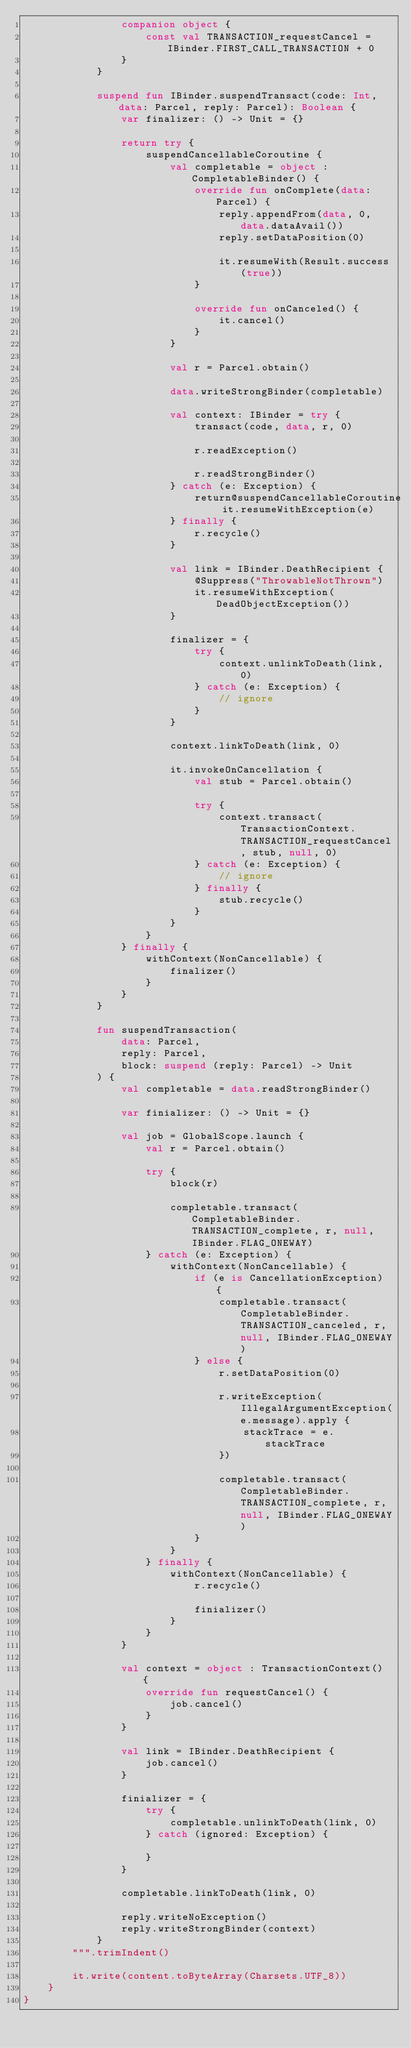<code> <loc_0><loc_0><loc_500><loc_500><_Kotlin_>                companion object {
                    const val TRANSACTION_requestCancel = IBinder.FIRST_CALL_TRANSACTION + 0
                }
            }

            suspend fun IBinder.suspendTransact(code: Int, data: Parcel, reply: Parcel): Boolean {
                var finalizer: () -> Unit = {}

                return try {
                    suspendCancellableCoroutine {
                        val completable = object : CompletableBinder() {
                            override fun onComplete(data: Parcel) {
                                reply.appendFrom(data, 0, data.dataAvail())
                                reply.setDataPosition(0)

                                it.resumeWith(Result.success(true))
                            }

                            override fun onCanceled() {
                                it.cancel()
                            }
                        }

                        val r = Parcel.obtain()

                        data.writeStrongBinder(completable)

                        val context: IBinder = try {
                            transact(code, data, r, 0)

                            r.readException()

                            r.readStrongBinder()
                        } catch (e: Exception) {
                            return@suspendCancellableCoroutine it.resumeWithException(e)
                        } finally {
                            r.recycle()
                        }

                        val link = IBinder.DeathRecipient {
                            @Suppress("ThrowableNotThrown")
                            it.resumeWithException(DeadObjectException())
                        }

                        finalizer = {
                            try {
                                context.unlinkToDeath(link, 0)
                            } catch (e: Exception) {
                                // ignore
                            }
                        }

                        context.linkToDeath(link, 0)

                        it.invokeOnCancellation {
                            val stub = Parcel.obtain()

                            try {
                                context.transact(TransactionContext.TRANSACTION_requestCancel, stub, null, 0)
                            } catch (e: Exception) {
                                // ignore
                            } finally {
                                stub.recycle()
                            }
                        }
                    }
                } finally {
                    withContext(NonCancellable) {
                        finalizer()
                    }
                }
            }

            fun suspendTransaction(
                data: Parcel,
                reply: Parcel,
                block: suspend (reply: Parcel) -> Unit
            ) {
                val completable = data.readStrongBinder()

                var finializer: () -> Unit = {}

                val job = GlobalScope.launch {
                    val r = Parcel.obtain()

                    try {
                        block(r)

                        completable.transact(CompletableBinder.TRANSACTION_complete, r, null, IBinder.FLAG_ONEWAY)
                    } catch (e: Exception) {
                        withContext(NonCancellable) {
                            if (e is CancellationException) {
                                completable.transact(CompletableBinder.TRANSACTION_canceled, r, null, IBinder.FLAG_ONEWAY)
                            } else {
                                r.setDataPosition(0)

                                r.writeException(IllegalArgumentException(e.message).apply {
                                    stackTrace = e.stackTrace
                                })

                                completable.transact(CompletableBinder.TRANSACTION_complete, r, null, IBinder.FLAG_ONEWAY)
                            }
                        }
                    } finally {
                        withContext(NonCancellable) {
                            r.recycle()

                            finializer()
                        }
                    }
                }

                val context = object : TransactionContext() {
                    override fun requestCancel() {
                        job.cancel()
                    }
                }

                val link = IBinder.DeathRecipient {
                    job.cancel()
                }

                finializer = {
                    try {
                        completable.unlinkToDeath(link, 0)
                    } catch (ignored: Exception) {

                    }
                }

                completable.linkToDeath(link, 0)

                reply.writeNoException()
                reply.writeStrongBinder(context)
            }
        """.trimIndent()

        it.write(content.toByteArray(Charsets.UTF_8))
    }
}</code> 